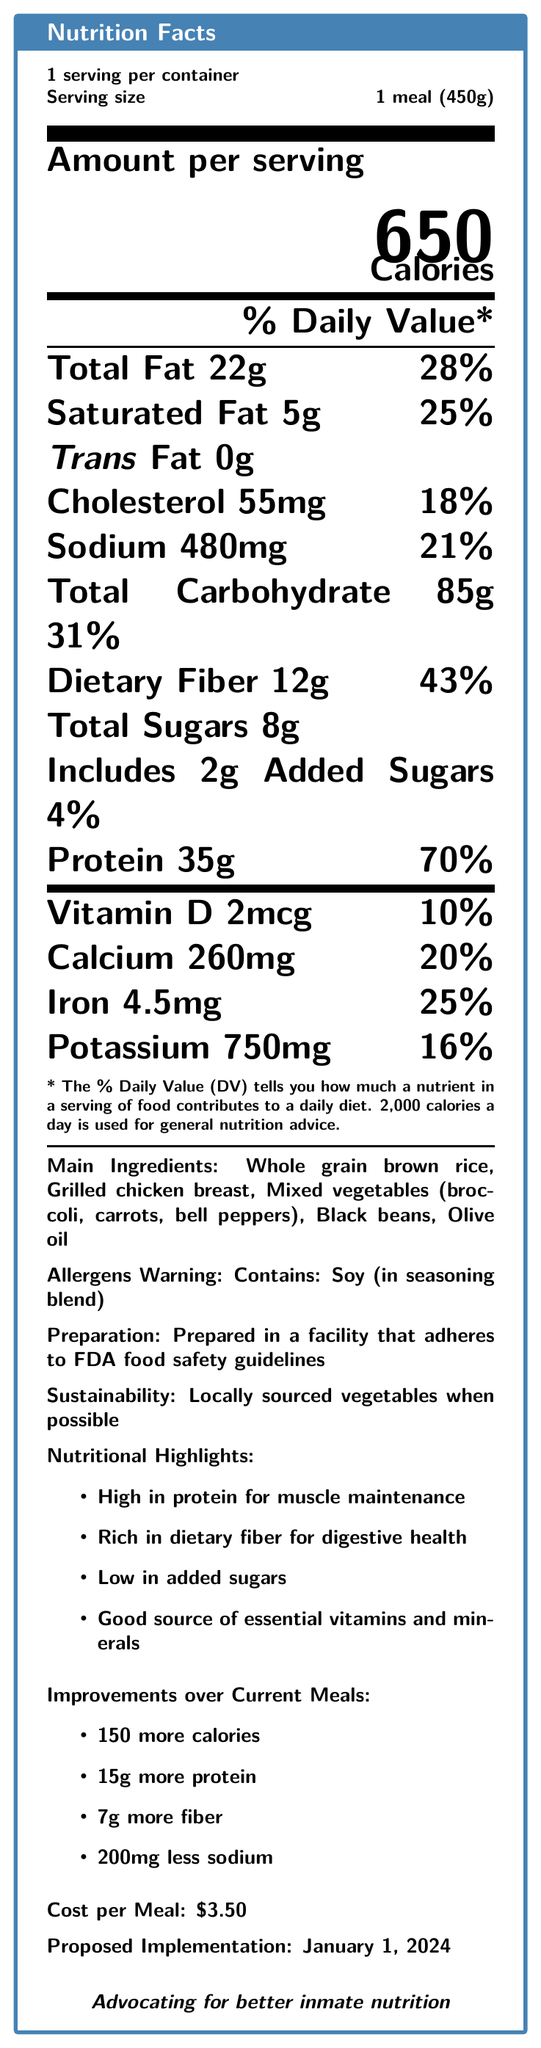what is the serving size of the meal? The document states "Serving size: 1 meal (450g)".
Answer: 1 meal (450g) how much protein does one serving of the proposed meal plan contain? Under the "Protein" section, it lists "35g".
Answer: 35g how much calcium is in one serving of the meal? The document indicates "Calcium: 260mg".
Answer: 260mg what percentage of the daily value of dietary fiber is in the meal? It states "Dietary Fiber: 12g \hfill 43%" in the % Daily Value section.
Answer: 43% what allergens are present in the meal? The document explicitly states "Allergens Warning: Contains: Soy (in seasoning blend)".
Answer: Soy how much does one meal cost? The cost per meal is mentioned as "$3.50".
Answer: $3.50 when is the proposed implementation date for the improved meal plan? "Proposed Implementation: January 1, 2024" is mentioned in the final section.
Answer: January 1, 2024 how many more calories does the proposed meal plan have compared to current meals? A. 100 B. 150 C. 200 D. 250 The "Improvements over Current Meals" section lists a "150 more calories".
Answer: B what are the main ingredients in the proposed meal? A. White rice, Chicken, Spinach, Kidney beans, Sunflower oil B. Whole grain brown rice, Grilled chicken breast, Mixed vegetables, Black beans, Olive oil C. Quinoa, Tofu, Mixed greens, Lentils, Coconut oil D. Pasta, Pork, Green beans, Chickpeas, Corn oil The document lists "Whole grain brown rice, Grilled chicken breast, Mixed vegetables (broccoli, carrots, bell peppers), Black beans, Olive oil".
Answer: B is the meal high in added sugars? Under the nutritional highlights, the document mentions "Low in added sugars".
Answer: No summarize the main points of the document The document provides a comprehensive overview of the nutritional content of the proposed meal, emphasizing improvements in nutritional value and the implementation date, while also considering cost and sustainability.
Answer: The document details the nutrition facts of a proposed improved meal plan for inmates. It includes information such as the serving size, calories, various nutrients, and allergens. It also highlights the benefits over current meals like higher protein and fiber content, reduced sodium, and sustainability efforts. The meal costs $3.50 and is set to be implemented on January 1, 2024. what is the total carbohydrate content per serving? The document indicates "Total Carbohydrate: 85g".
Answer: 85g how much saturated fat does one serving contain? It states "Saturated Fat: 5g".
Answer: 5g what is the main source of protein in the meal? Among the listed main ingredients, grilled chicken breast is the primary protein source.
Answer: Grilled chicken breast which vitamin is present at 10% of the daily value? A. Vitamin A B. Vitamin C C. Vitamin D D. Vitamin B12 The document specifies "Vitamin D: 2mcg \hfill 10%".
Answer: C how much sodium does the meal contain? It states "Sodium: 480mg".
Answer: 480mg what preparation standards does the facility follow? The document mentions the facility adheres to "FDA food safety guidelines".
Answer: FDA food safety guidelines are all vegetables in the meal locally sourced? The document states "Locally sourced vegetables when possible" but does not specify the proportion.
Answer: Not enough information 